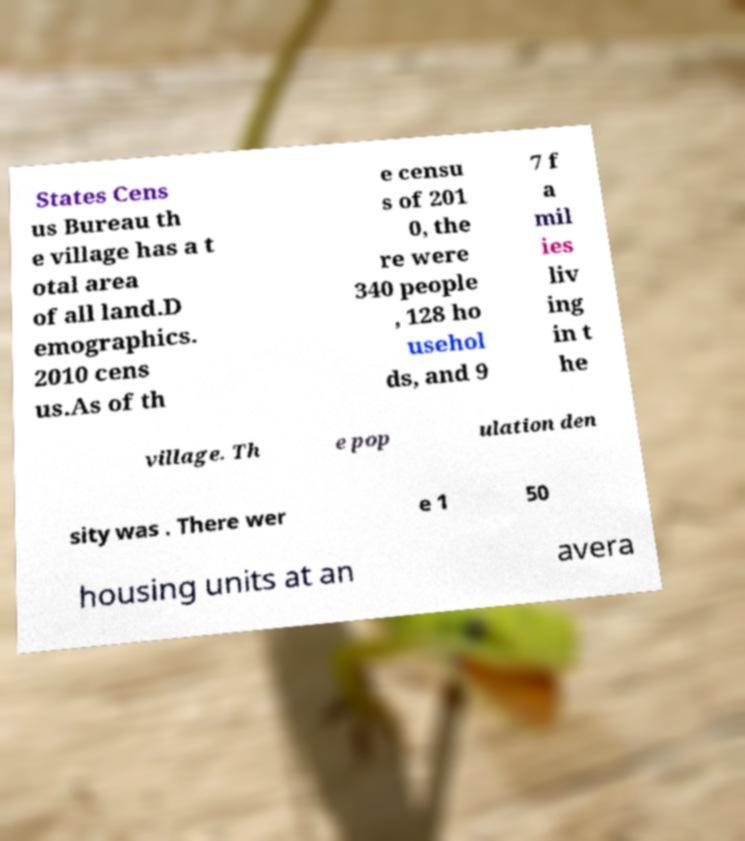I need the written content from this picture converted into text. Can you do that? States Cens us Bureau th e village has a t otal area of all land.D emographics. 2010 cens us.As of th e censu s of 201 0, the re were 340 people , 128 ho usehol ds, and 9 7 f a mil ies liv ing in t he village. Th e pop ulation den sity was . There wer e 1 50 housing units at an avera 